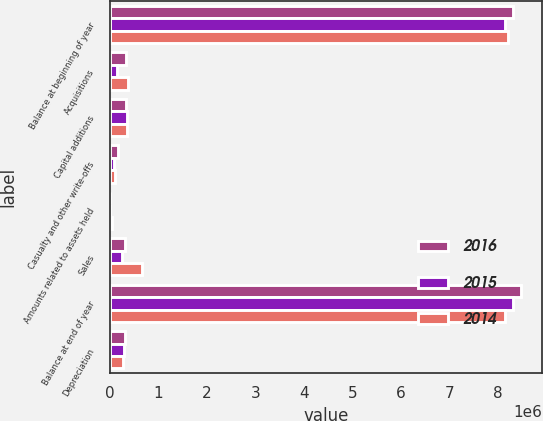<chart> <loc_0><loc_0><loc_500><loc_500><stacked_bar_chart><ecel><fcel>Balance at beginning of year<fcel>Acquisitions<fcel>Capital additions<fcel>Casualty and other write-offs<fcel>Amounts related to assets held<fcel>Sales<fcel>Balance at end of year<fcel>Depreciation<nl><fcel>2016<fcel>8.30748e+06<fcel>333174<fcel>338606<fcel>166703<fcel>2801<fcel>323593<fcel>8.48617e+06<fcel>312365<nl><fcel>2015<fcel>8.14496e+06<fcel>147077<fcel>362948<fcel>79561<fcel>7036<fcel>260903<fcel>8.30748e+06<fcel>285514<nl><fcel>2014<fcel>8.21408e+06<fcel>379187<fcel>367454<fcel>111068<fcel>38744<fcel>665952<fcel>8.14496e+06<fcel>265060<nl></chart> 